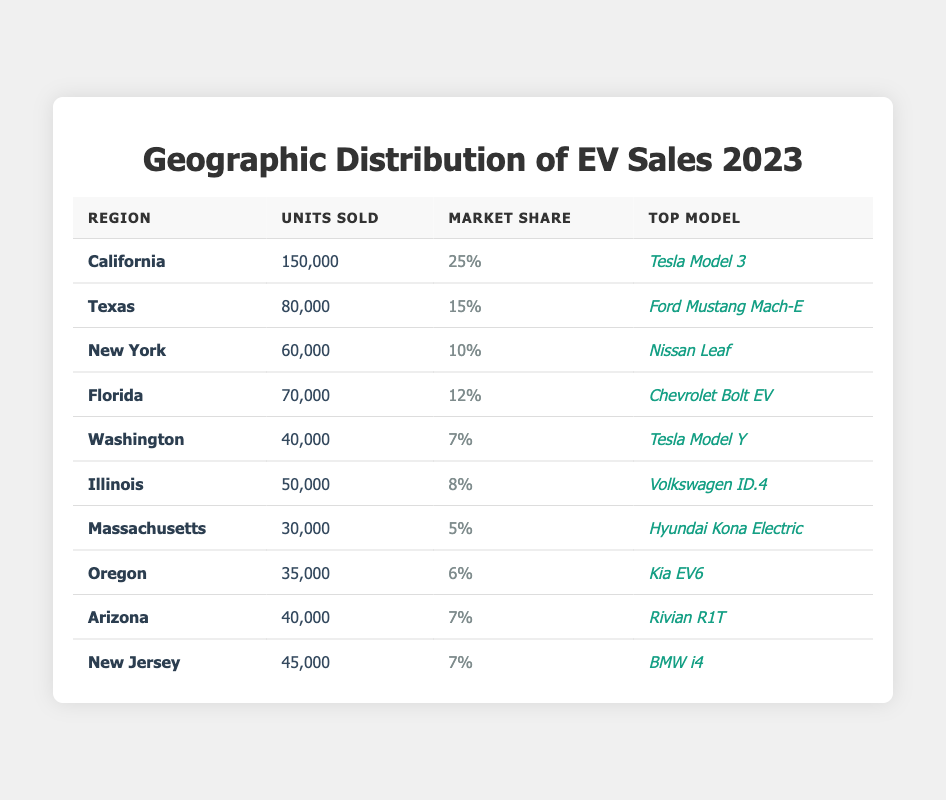What is the top-selling electric vehicle model in California? The table lists the top model for each region. For California, the top model is mentioned as "Tesla Model 3."
Answer: Tesla Model 3 How many units of electric vehicles were sold in Texas? Referring to the table, the number of units sold in Texas is stated as 80,000.
Answer: 80,000 What is the total number of electric vehicles sold in New York and Florida combined? To find the total, add the units sold in New York (60,000) to those sold in Florida (70,000): 60,000 + 70,000 = 130,000.
Answer: 130,000 Which region has the highest market share for electric vehicles? The table shows California with the highest market share of 25%.
Answer: California True or False: The market share percentage for Washington is higher than that of Illinois. The market share for Washington is 7%, and for Illinois, it is 8%. Since 7% is not higher than 8%, the statement is false.
Answer: False What is the average number of electric vehicles sold across all the regions listed? First, add the total units sold: 150,000 + 80,000 + 60,000 + 70,000 + 40,000 + 50,000 + 30,000 + 35,000 + 40,000 + 45,000 which equals 600,000. Then divide by the number of regions (10): 600,000 / 10 = 60,000.
Answer: 60,000 Which electric vehicle model sold the least in Massachusetts? The table shows that Massachusetts had 30,000 units sold, which is the only data for that region, and the only model listed is "Hyundai Kona Electric." Therefore, this model is the least in that specific region.
Answer: Hyundai Kona Electric Which two regions had the same market share percentage? Referring to the table, both Arizona and New Jersey have a market share of 7%.
Answer: Arizona and New Jersey What is the difference in units sold between California and Florida? California had 150,000 units sold, while Florida had 70,000. The difference is 150,000 - 70,000 = 80,000.
Answer: 80,000 If you combine the units sold in Illinois and Massachusetts, what would that total be? The total units sold in Illinois is 50,000 and in Massachusetts is 30,000. Adding them gives 50,000 + 30,000 = 80,000.
Answer: 80,000 